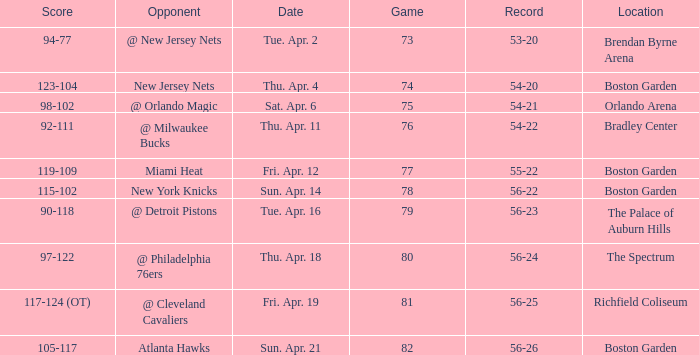When was the score 56-26? Sun. Apr. 21. 